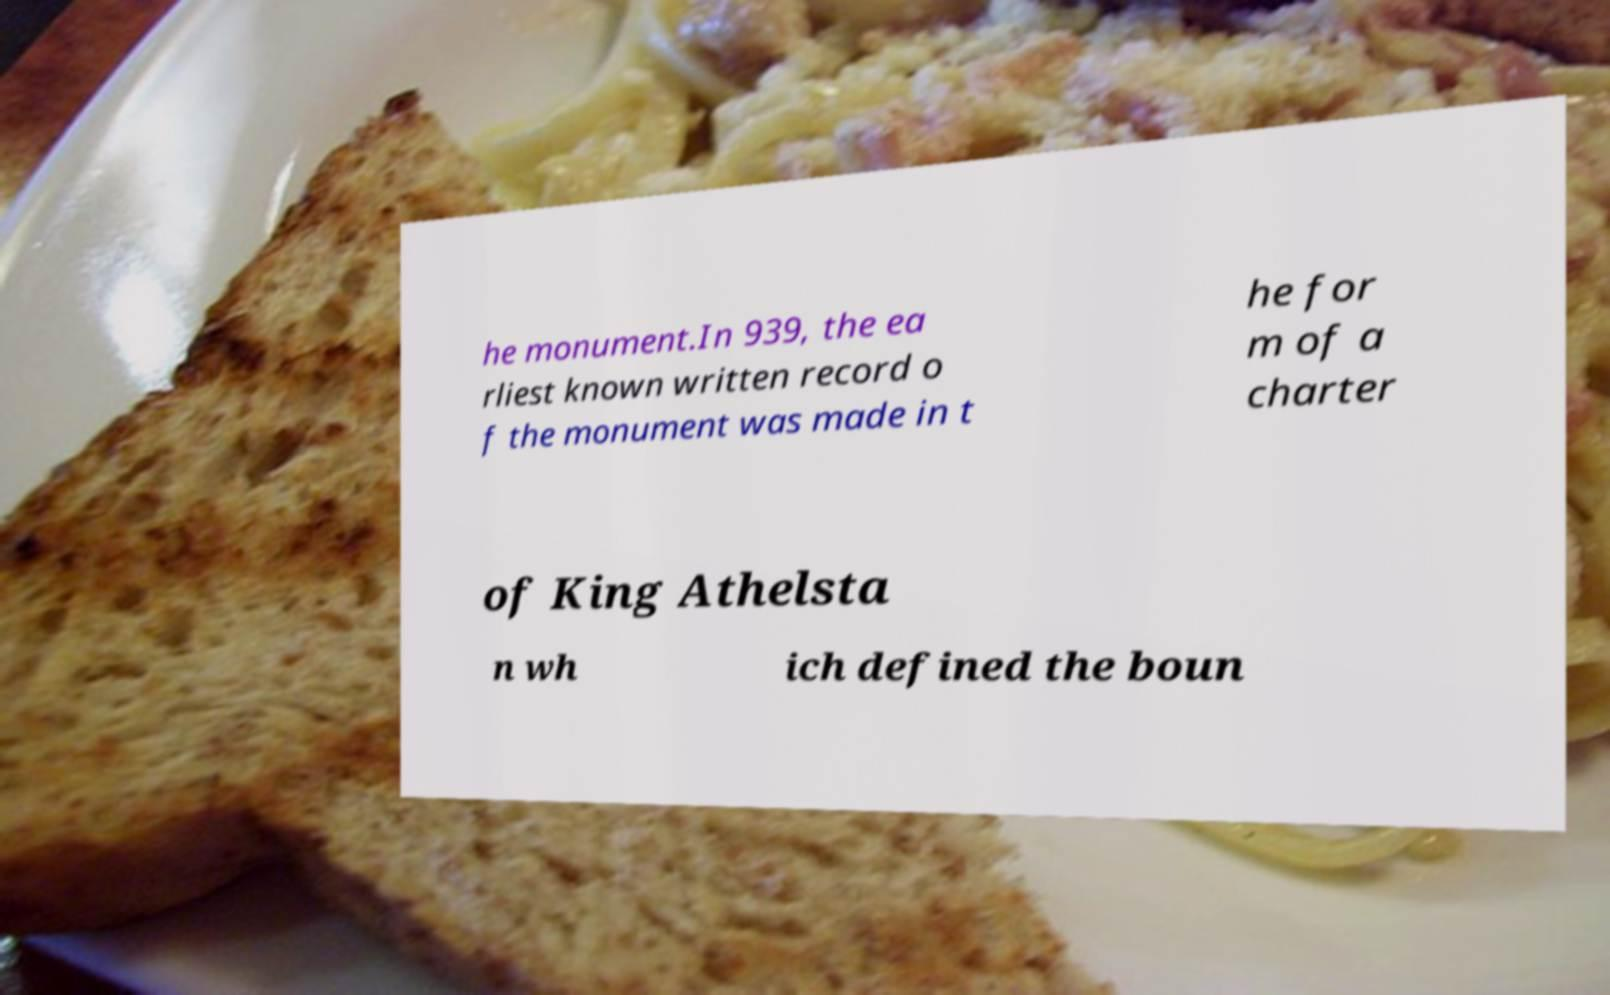Could you extract and type out the text from this image? he monument.In 939, the ea rliest known written record o f the monument was made in t he for m of a charter of King Athelsta n wh ich defined the boun 